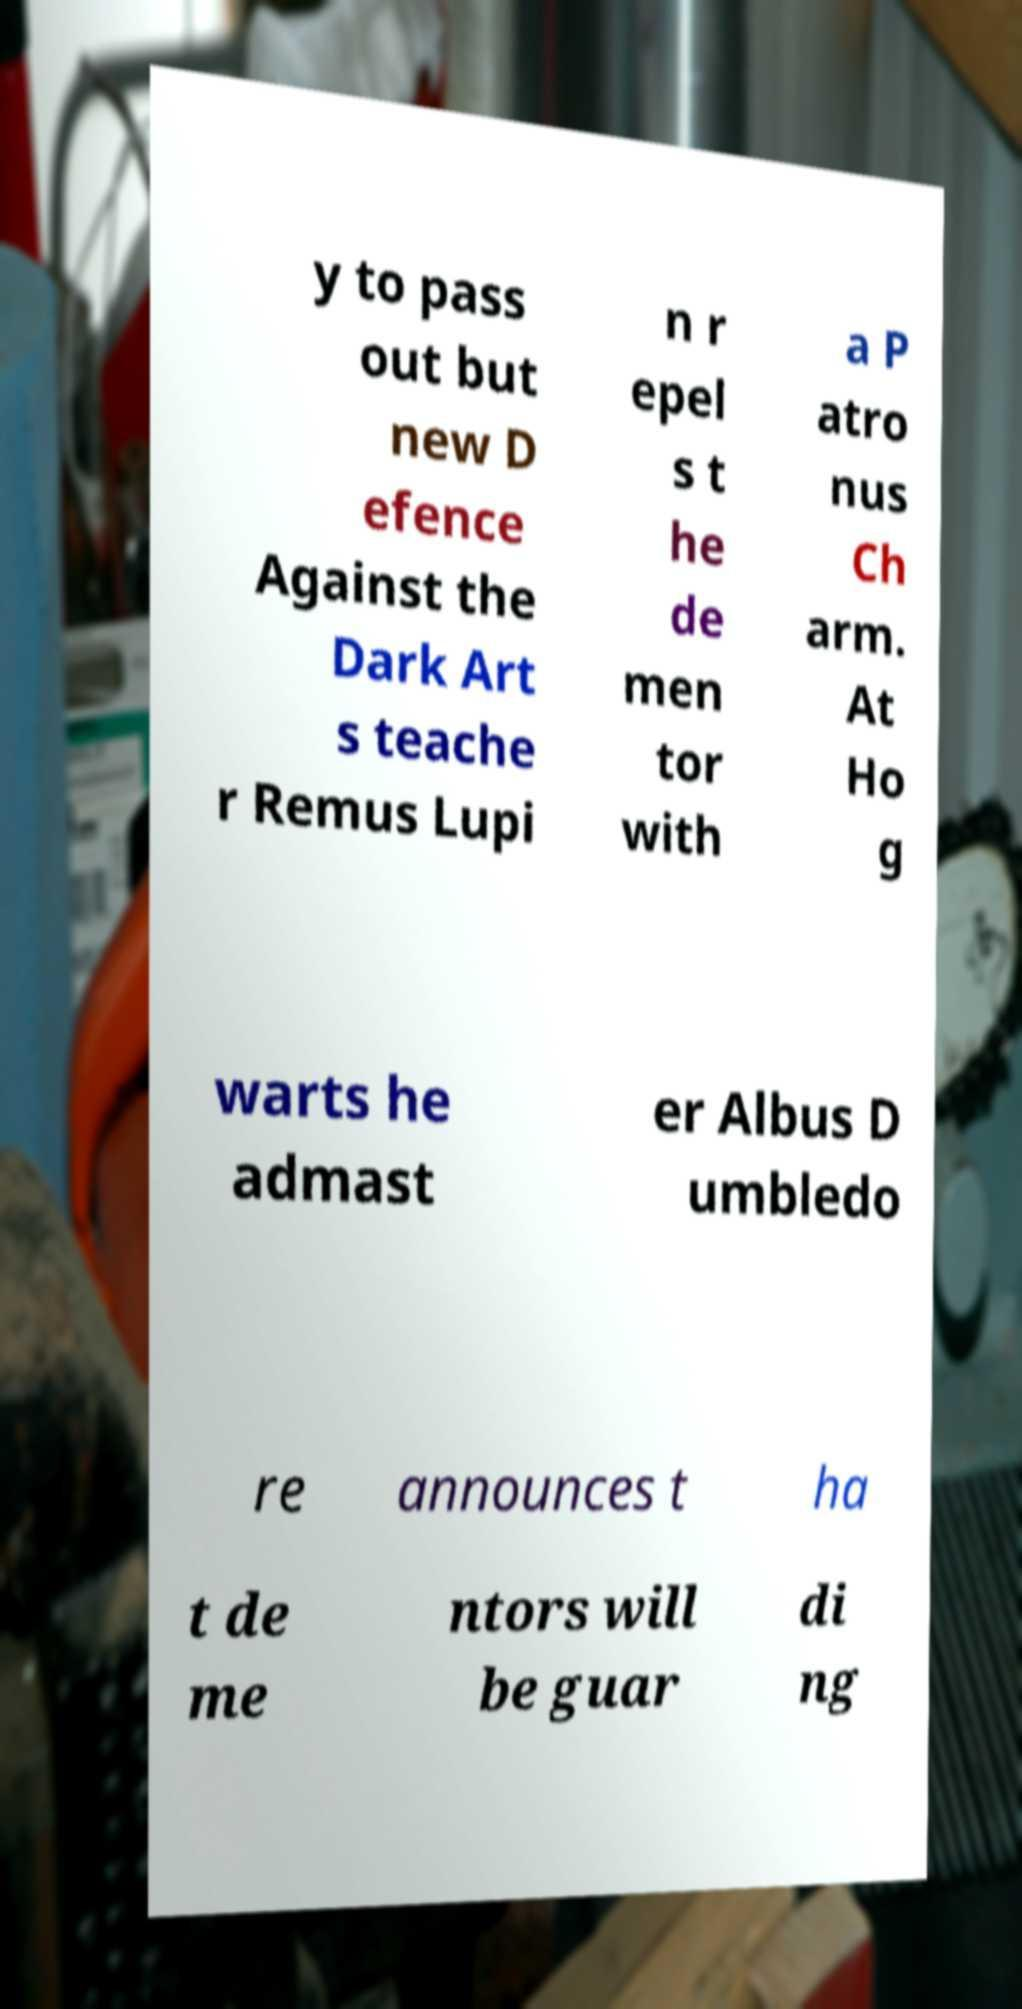Could you assist in decoding the text presented in this image and type it out clearly? y to pass out but new D efence Against the Dark Art s teache r Remus Lupi n r epel s t he de men tor with a P atro nus Ch arm. At Ho g warts he admast er Albus D umbledo re announces t ha t de me ntors will be guar di ng 